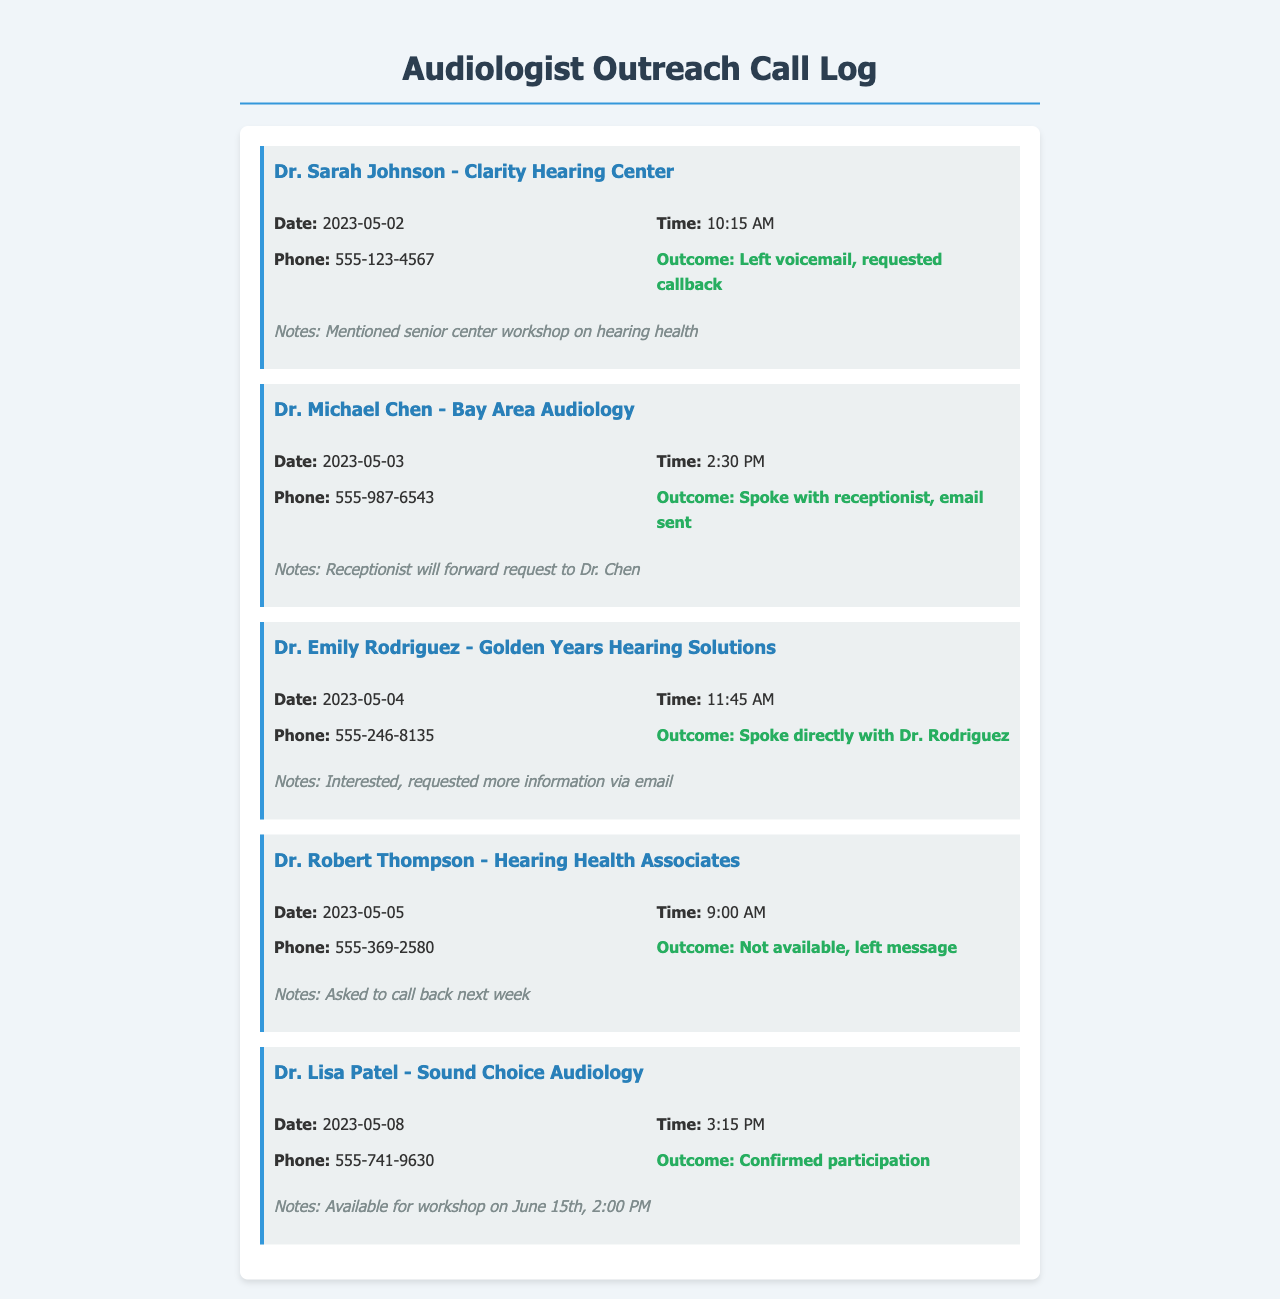What is the name of the first audiologist contacted? The first audiologist in the log is Dr. Sarah Johnson from Clarity Hearing Center.
Answer: Dr. Sarah Johnson What was the outcome of the call to Dr. Michael Chen? The call outcome for Dr. Michael Chen was that the receptionist answered and an email was sent.
Answer: Spoke with receptionist, email sent What is the date of Dr. Lisa Patel's confirmed participation? The date for Dr. Lisa Patel's confirmed participation in the workshop is June 15th.
Answer: June 15th How many audiologists were contacted in total? The log shows a total of five outreach attempts to audiologists.
Answer: Five What time was the call made to Dr. Emily Rodriguez? The call to Dr. Emily Rodriguez was made at 11:45 AM.
Answer: 11:45 AM What did the receptionist at Bay Area Audiology promise? The receptionist promised to forward the request to Dr. Chen.
Answer: Forward request to Dr. Chen What was left for Dr. Robert Thompson? A message was left for Dr. Robert Thompson since he was not available.
Answer: Left message What workshop topic was mentioned in the call with Dr. Sarah Johnson? The workshop topic mentioned was hearing health.
Answer: Hearing health What is the phone number of Sound Choice Audiology? The phone number for Sound Choice Audiology is 555-741-9630.
Answer: 555-741-9630 